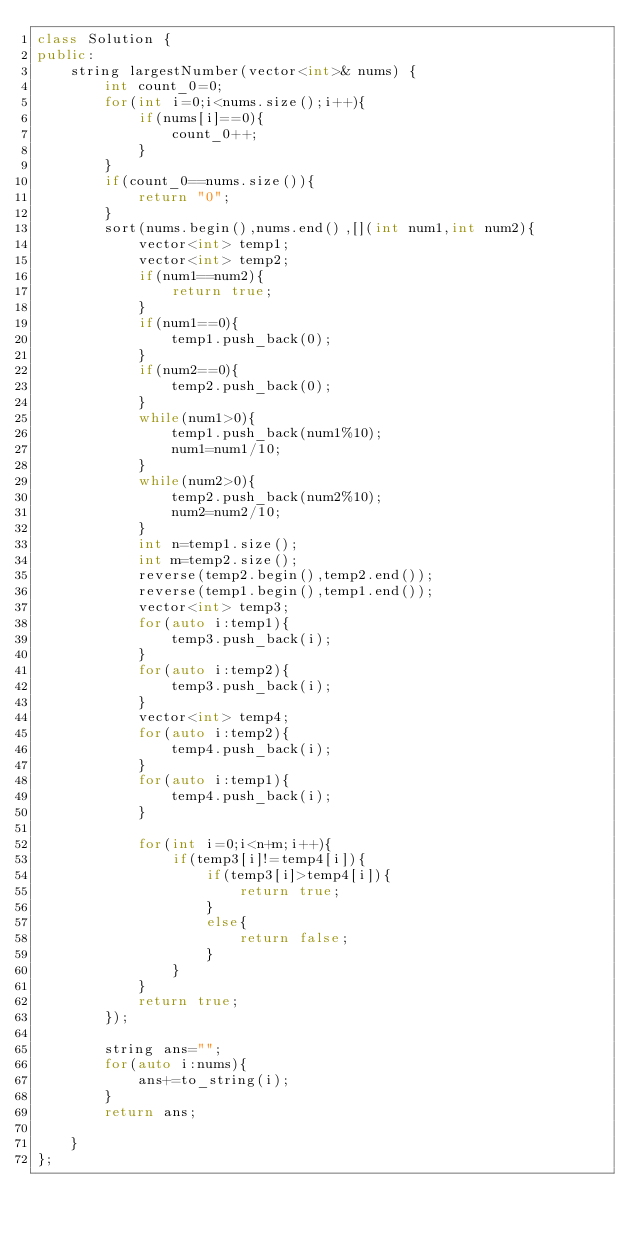<code> <loc_0><loc_0><loc_500><loc_500><_C++_>class Solution {
public:
    string largestNumber(vector<int>& nums) {
        int count_0=0;
        for(int i=0;i<nums.size();i++){
            if(nums[i]==0){
                count_0++;
            }
        }
        if(count_0==nums.size()){
            return "0";
        }
        sort(nums.begin(),nums.end(),[](int num1,int num2){
            vector<int> temp1;
            vector<int> temp2;
            if(num1==num2){
                return true;
            }
            if(num1==0){
                temp1.push_back(0);
            }
            if(num2==0){
                temp2.push_back(0);
            }
            while(num1>0){
                temp1.push_back(num1%10);
                num1=num1/10;
            }
            while(num2>0){
                temp2.push_back(num2%10);
                num2=num2/10;
            }
            int n=temp1.size();
            int m=temp2.size();
            reverse(temp2.begin(),temp2.end());
            reverse(temp1.begin(),temp1.end());
            vector<int> temp3;
            for(auto i:temp1){
                temp3.push_back(i);
            }
            for(auto i:temp2){
                temp3.push_back(i);
            }
            vector<int> temp4;
            for(auto i:temp2){
                temp4.push_back(i);
            }
            for(auto i:temp1){
                temp4.push_back(i);
            }
            
            for(int i=0;i<n+m;i++){
                if(temp3[i]!=temp4[i]){
                    if(temp3[i]>temp4[i]){
                        return true;
                    }
                    else{
                        return false;
                    }
                }
            }
            return true;
        });
        
        string ans="";
        for(auto i:nums){
            ans+=to_string(i);
        }
        return ans;
        
    }
};</code> 